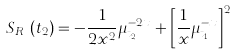<formula> <loc_0><loc_0><loc_500><loc_500>S _ { R _ { \mu } } ( t _ { 2 } ) = - \frac { 1 } { 2 x ^ { 2 } } \mu _ { t _ { 2 } } ^ { - 2 x } + \left [ \frac { 1 } { x } \mu _ { t _ { 1 } } ^ { - x } \right ] ^ { 2 }</formula> 